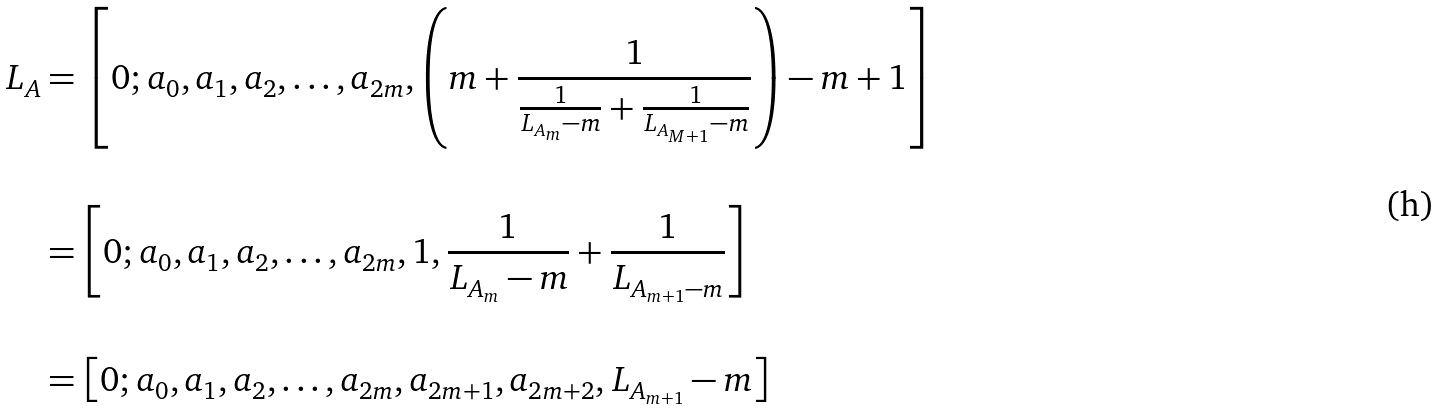<formula> <loc_0><loc_0><loc_500><loc_500>L _ { A } & = \left [ 0 ; a _ { 0 } , a _ { 1 } , a _ { 2 } , \dots , a _ { 2 m } , \left ( m + \frac { 1 } { \frac { 1 } { L _ { A _ { m } } - m } + \frac { 1 } { L _ { A _ { M + 1 } } - m } } \right ) - m + 1 \right ] \\ \\ & = \left [ 0 ; a _ { 0 } , a _ { 1 } , a _ { 2 } , \dots , a _ { 2 m } , 1 , \frac { 1 } { L _ { A _ { m } } - m } + \frac { 1 } { L _ { A _ { m + 1 } - m } } \right ] \\ \\ & = \left [ 0 ; a _ { 0 } , a _ { 1 } , a _ { 2 } , \dots , a _ { 2 m } , a _ { 2 m + 1 } , a _ { 2 m + 2 } , L _ { A _ { m + 1 } } - m \right ]</formula> 